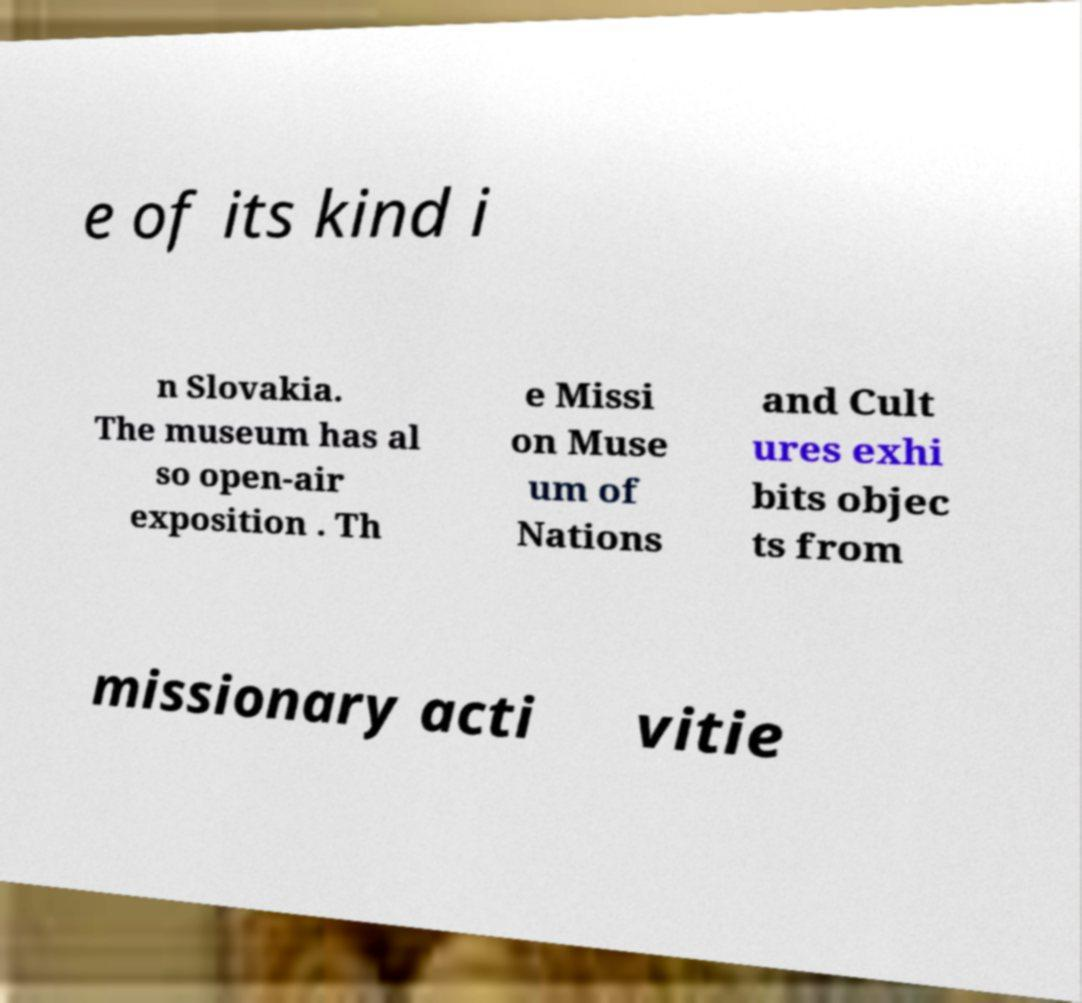Please read and relay the text visible in this image. What does it say? e of its kind i n Slovakia. The museum has al so open-air exposition . Th e Missi on Muse um of Nations and Cult ures exhi bits objec ts from missionary acti vitie 